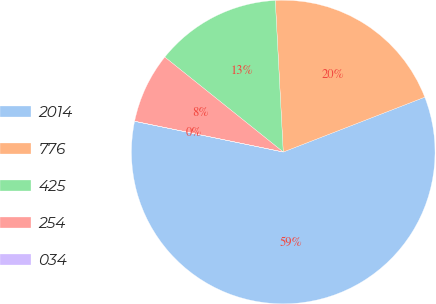<chart> <loc_0><loc_0><loc_500><loc_500><pie_chart><fcel>2014<fcel>776<fcel>425<fcel>254<fcel>034<nl><fcel>59.12%<fcel>19.95%<fcel>13.41%<fcel>7.5%<fcel>0.01%<nl></chart> 